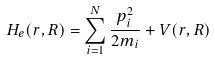Convert formula to latex. <formula><loc_0><loc_0><loc_500><loc_500>H _ { e } ( { r , R } ) = \sum _ { i = 1 } ^ { N } { \frac { { p } _ { i } ^ { 2 } } { 2 m _ { i } } } + V ( { r , R } )</formula> 